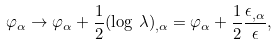Convert formula to latex. <formula><loc_0><loc_0><loc_500><loc_500>\varphi _ { \alpha } \rightarrow \varphi _ { \alpha } + \frac { 1 } { 2 } ( \log \, \lambda ) _ { , \alpha } = \varphi _ { \alpha } + \frac { 1 } { 2 } \frac { \epsilon _ { , \alpha } } { \epsilon } ,</formula> 